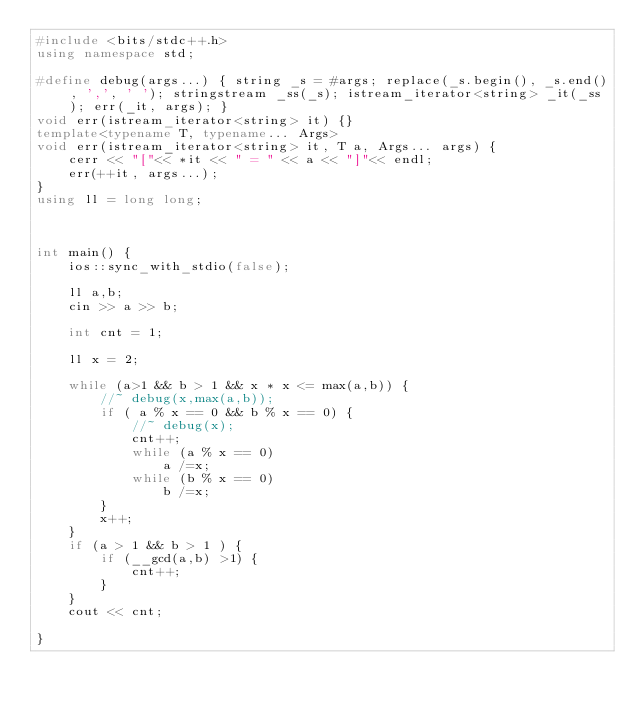Convert code to text. <code><loc_0><loc_0><loc_500><loc_500><_C++_>#include <bits/stdc++.h>
using namespace std;

#define debug(args...) { string _s = #args; replace(_s.begin(), _s.end(), ',', ' '); stringstream _ss(_s); istream_iterator<string> _it(_ss); err(_it, args); }
void err(istream_iterator<string> it) {}
template<typename T, typename... Args>
void err(istream_iterator<string> it, T a, Args... args) {
    cerr << "["<< *it << " = " << a << "]"<< endl;
    err(++it, args...);
}
using ll = long long;



int main() {
    ios::sync_with_stdio(false);

    ll a,b;
    cin >> a >> b;

    int cnt = 1;

    ll x = 2;

    while (a>1 && b > 1 && x * x <= max(a,b)) {
        //~ debug(x,max(a,b));
        if ( a % x == 0 && b % x == 0) {
            //~ debug(x);
            cnt++;
            while (a % x == 0)
                a /=x;
            while (b % x == 0)
                b /=x;
        }
        x++;
    }
    if (a > 1 && b > 1 ) {
        if (__gcd(a,b) >1) {
            cnt++;
        }
    }
    cout << cnt;

}
</code> 